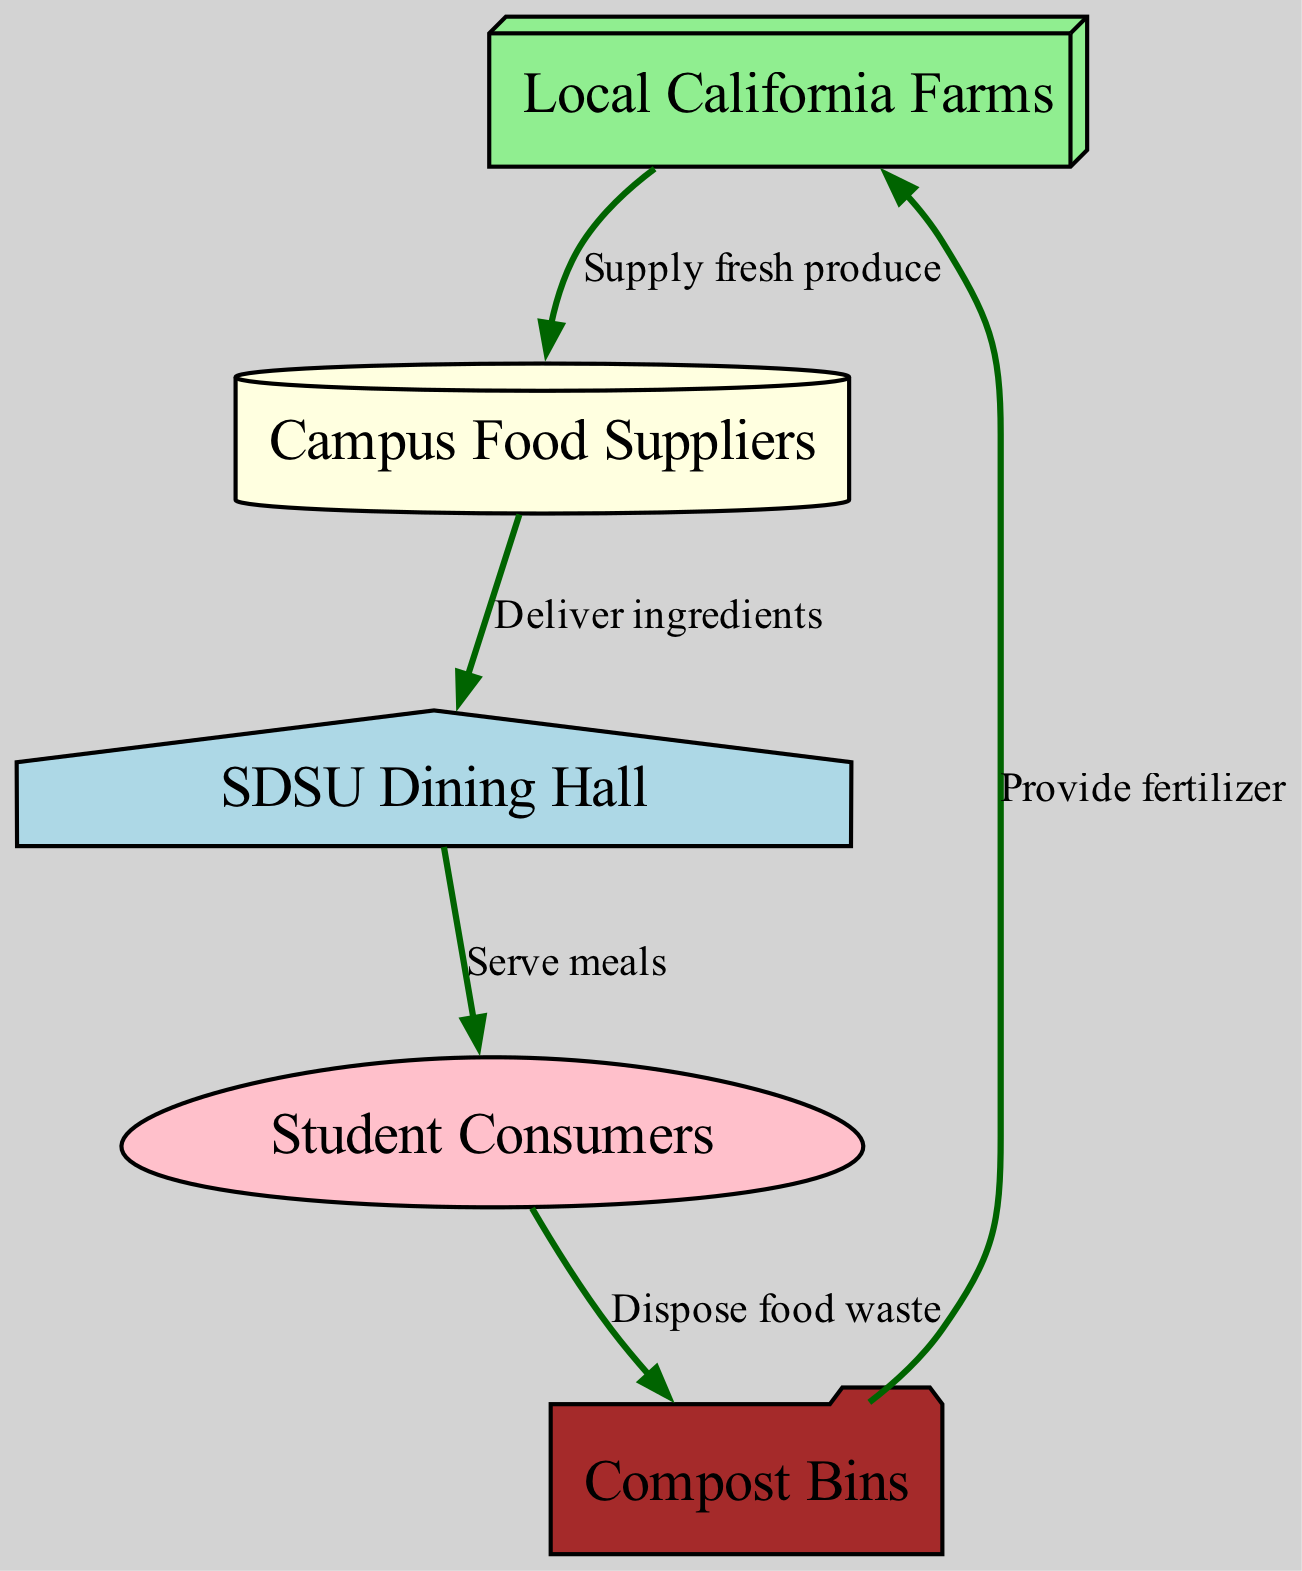What is the first node in the food chain? The first node is "Local California Farms," which is the starting point for the food chain process. It signifies the source of fresh produce that initiates the entire flow of food.
Answer: Local California Farms How many nodes are in the food chain? The diagram shows a total of five nodes: "Local California Farms," "Campus Food Suppliers," "SDSU Dining Hall," "Student Consumers," and "Compost Bins."
Answer: 5 What is the relationship between "Campus Food Suppliers" and "SDSU Dining Hall"? The relationship is that "Campus Food Suppliers" delivers ingredients to the "SDSU Dining Hall," indicating the flow of food supplies from the suppliers to the dining hall for meal preparation.
Answer: Deliver ingredients What do students do with food waste? Students dispose of food waste into the "Compost Bins," which is an essential part of managing food consumption and waste on campus.
Answer: Dispose food waste What role does "Compost Bins" play after student consumption? The "Compost Bins" provide fertilizer, creating a cycle that benefits the local farms by returning nutrients to the soil, completing the food cycle.
Answer: Provide fertilizer How many edges are shown in the diagram? The diagram indicates four edges, depicting the connections between nodes that represent the flow of food from farms to students and back to farms via composting.
Answer: 4 What is the color of the "SDSU Dining Hall" node? The "SDSU Dining Hall" node is colored light blue, distinguishing it visually from the other nodes within the diagram.
Answer: Light blue Who are the ultimate consumers in this food chain? The ultimate consumers in this food chain are the "Student Consumers," as they are the final recipients of the meals served by the dining hall.
Answer: Student Consumers What is the last step of the food chain depicted in the diagram? The last step of the food chain is the process where food waste is disposed of into the "Compost Bins," ensuring waste is recycled back into usable resources.
Answer: Dispose food waste 